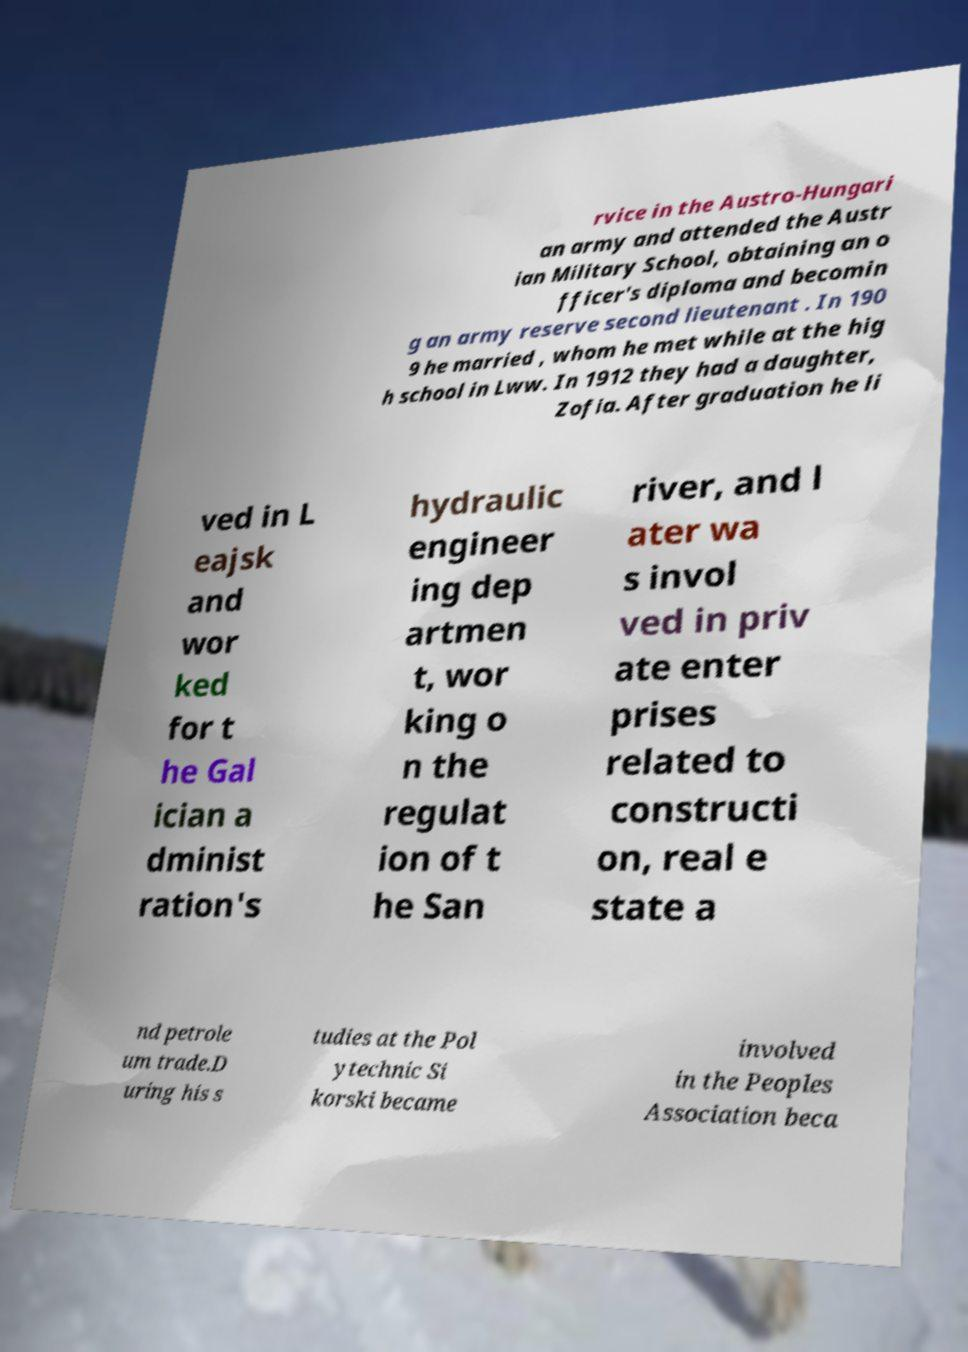There's text embedded in this image that I need extracted. Can you transcribe it verbatim? rvice in the Austro-Hungari an army and attended the Austr ian Military School, obtaining an o fficer's diploma and becomin g an army reserve second lieutenant . In 190 9 he married , whom he met while at the hig h school in Lww. In 1912 they had a daughter, Zofia. After graduation he li ved in L eajsk and wor ked for t he Gal ician a dminist ration's hydraulic engineer ing dep artmen t, wor king o n the regulat ion of t he San river, and l ater wa s invol ved in priv ate enter prises related to constructi on, real e state a nd petrole um trade.D uring his s tudies at the Pol ytechnic Si korski became involved in the Peoples Association beca 